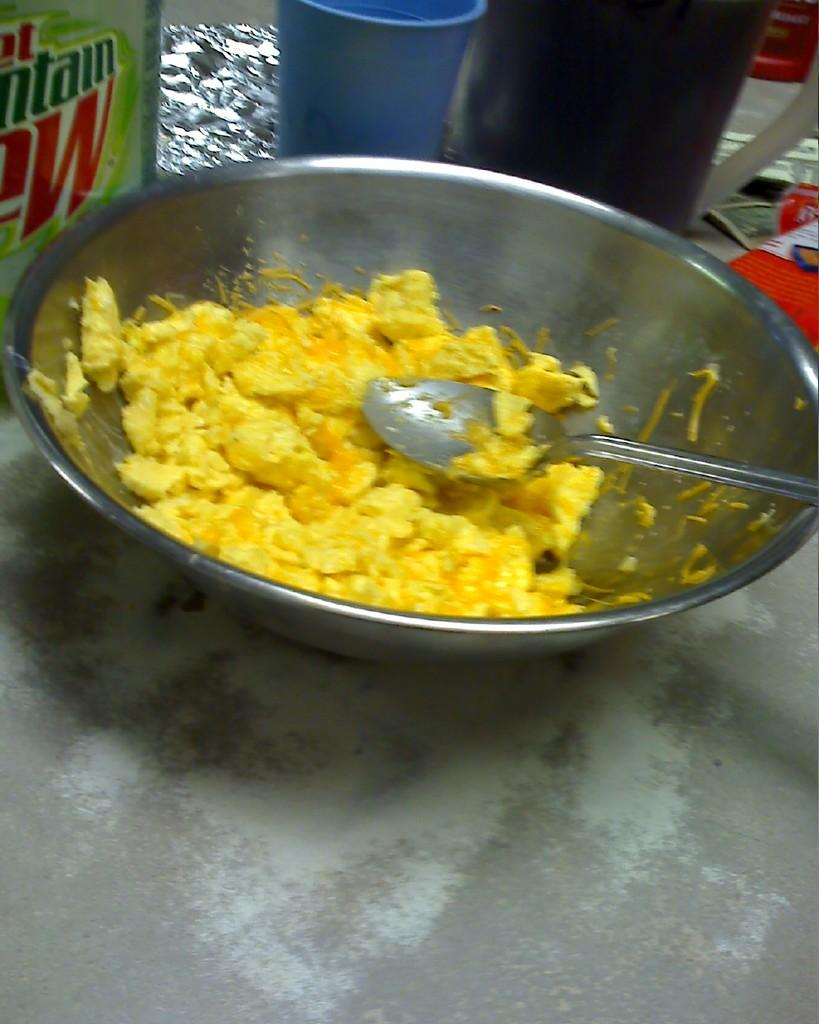What is in the bowl that is visible in the image? There is a bowl with food items in the image. What utensil is present in the image? There is a spoon in the image. What type of containers can be seen in the image? There are glasses in the image. What type of covering is present in the image? There are plastic covers in the image. What else can be seen in the image related to eating or serving food? There are utensils in the image. Can you describe the setting where the image might have been taken? The image may have been taken in a room. What type of rhythm is being played in the background of the image? There is no indication of any music or rhythm in the image, as it primarily focuses on food items and related items. 